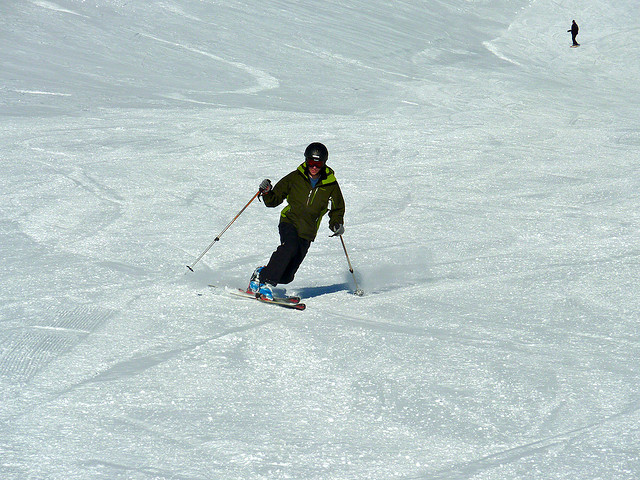<image>How old is he? It is unanswerable how old he is. What country is this in? I am not sure about the country, it could be the United States or Greenland. How old is he? He's age is ambiguous. It can be any of ['25', '30', '17', 'young', '20', '12', '13', '37', "i don't know", '21']. What country is this in? I don't know which country this is in. It can be America, USA, or Greenland. 